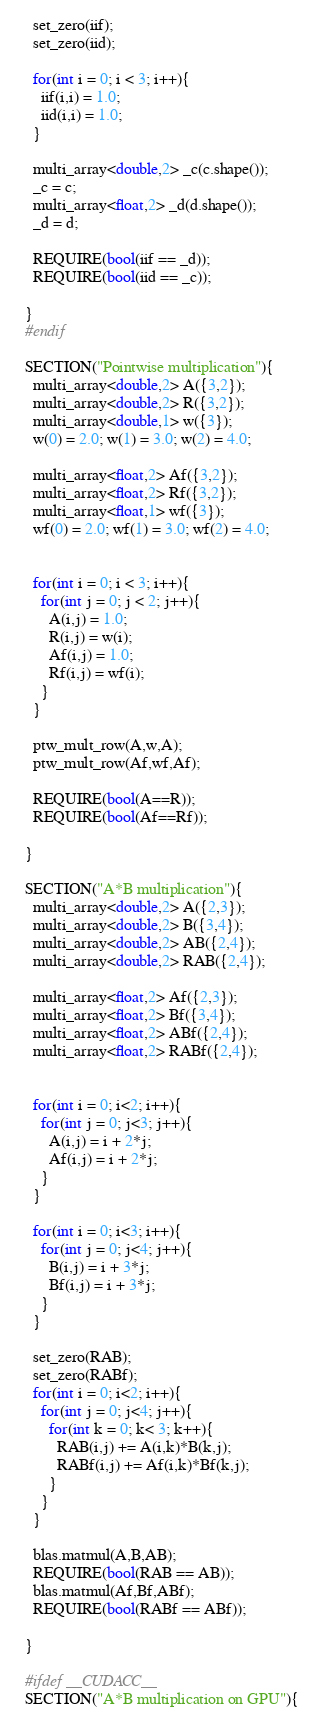Convert code to text. <code><loc_0><loc_0><loc_500><loc_500><_C++_>    set_zero(iif);
    set_zero(iid);

    for(int i = 0; i < 3; i++){
      iif(i,i) = 1.0;
      iid(i,i) = 1.0;
    }

    multi_array<double,2> _c(c.shape());
    _c = c;
    multi_array<float,2> _d(d.shape());
    _d = d;

    REQUIRE(bool(iif == _d));
    REQUIRE(bool(iid == _c));

  }
  #endif

  SECTION("Pointwise multiplication"){
    multi_array<double,2> A({3,2});
    multi_array<double,2> R({3,2});
    multi_array<double,1> w({3});
    w(0) = 2.0; w(1) = 3.0; w(2) = 4.0;

    multi_array<float,2> Af({3,2});
    multi_array<float,2> Rf({3,2});
    multi_array<float,1> wf({3});
    wf(0) = 2.0; wf(1) = 3.0; wf(2) = 4.0;


    for(int i = 0; i < 3; i++){
      for(int j = 0; j < 2; j++){
        A(i,j) = 1.0;
        R(i,j) = w(i);
        Af(i,j) = 1.0;
        Rf(i,j) = wf(i);
      }
    }

    ptw_mult_row(A,w,A);
    ptw_mult_row(Af,wf,Af);

    REQUIRE(bool(A==R));
    REQUIRE(bool(Af==Rf));

  }

  SECTION("A*B multiplication"){
    multi_array<double,2> A({2,3});
    multi_array<double,2> B({3,4});
    multi_array<double,2> AB({2,4});
    multi_array<double,2> RAB({2,4});

    multi_array<float,2> Af({2,3});
    multi_array<float,2> Bf({3,4});
    multi_array<float,2> ABf({2,4});
    multi_array<float,2> RABf({2,4});


    for(int i = 0; i<2; i++){
      for(int j = 0; j<3; j++){
        A(i,j) = i + 2*j;
        Af(i,j) = i + 2*j;
      }
    }

    for(int i = 0; i<3; i++){
      for(int j = 0; j<4; j++){
        B(i,j) = i + 3*j;
        Bf(i,j) = i + 3*j;
      }
    }

    set_zero(RAB);
    set_zero(RABf);
    for(int i = 0; i<2; i++){
      for(int j = 0; j<4; j++){
        for(int k = 0; k< 3; k++){
          RAB(i,j) += A(i,k)*B(k,j);
          RABf(i,j) += Af(i,k)*Bf(k,j);
        }
      }
    }

    blas.matmul(A,B,AB);
    REQUIRE(bool(RAB == AB));
    blas.matmul(Af,Bf,ABf);
    REQUIRE(bool(RABf == ABf));

  }

  #ifdef __CUDACC__
  SECTION("A*B multiplication on GPU"){</code> 